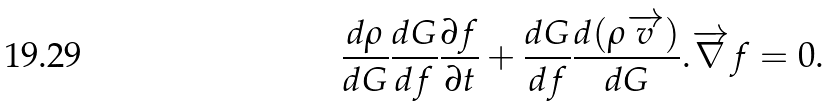Convert formula to latex. <formula><loc_0><loc_0><loc_500><loc_500>\frac { d \rho } { d G } \frac { d G } { d f } \frac { \partial f } { \partial t } + \frac { d G } { d f } \frac { d ( \rho \overrightarrow { v } ) } { d G } . \overrightarrow { \nabla } f = 0 .</formula> 